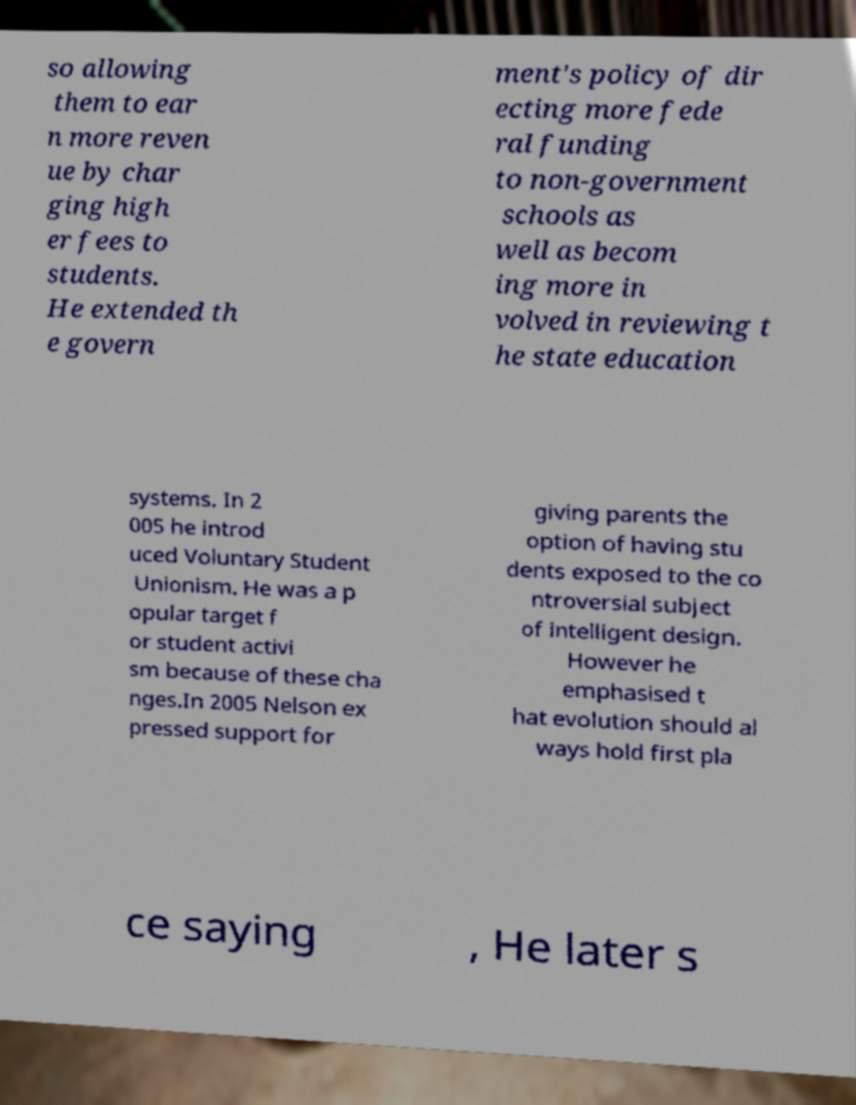Please identify and transcribe the text found in this image. so allowing them to ear n more reven ue by char ging high er fees to students. He extended th e govern ment's policy of dir ecting more fede ral funding to non-government schools as well as becom ing more in volved in reviewing t he state education systems. In 2 005 he introd uced Voluntary Student Unionism. He was a p opular target f or student activi sm because of these cha nges.In 2005 Nelson ex pressed support for giving parents the option of having stu dents exposed to the co ntroversial subject of intelligent design. However he emphasised t hat evolution should al ways hold first pla ce saying , He later s 